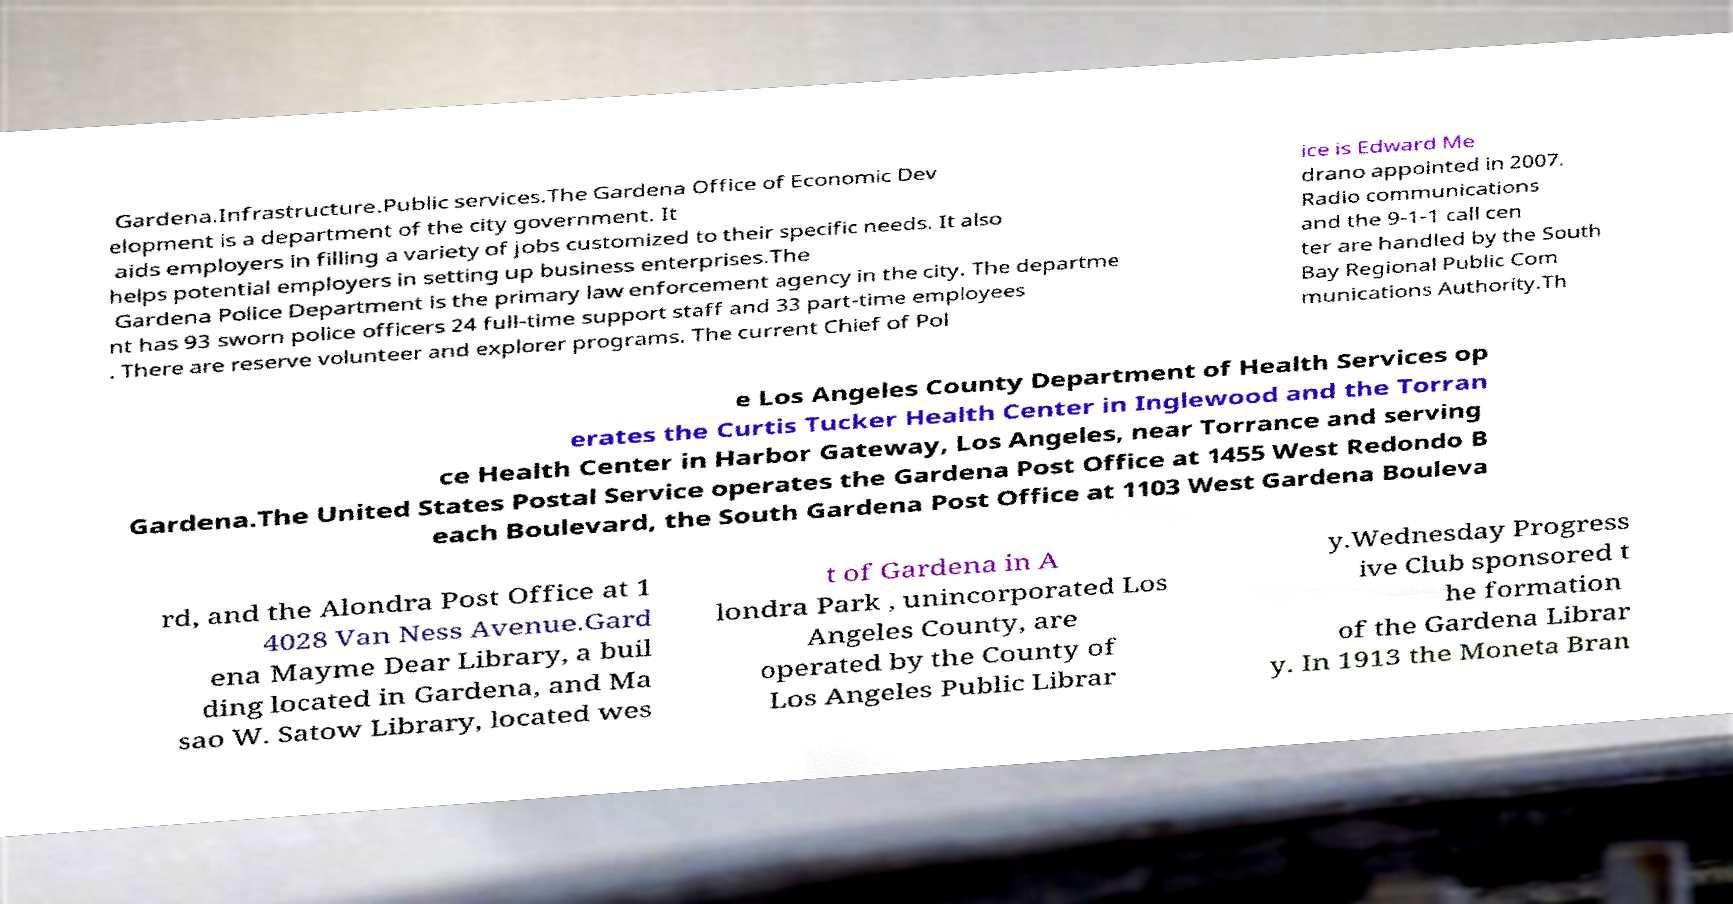Could you assist in decoding the text presented in this image and type it out clearly? Gardena.Infrastructure.Public services.The Gardena Office of Economic Dev elopment is a department of the city government. It aids employers in filling a variety of jobs customized to their specific needs. It also helps potential employers in setting up business enterprises.The Gardena Police Department is the primary law enforcement agency in the city. The departme nt has 93 sworn police officers 24 full-time support staff and 33 part-time employees . There are reserve volunteer and explorer programs. The current Chief of Pol ice is Edward Me drano appointed in 2007. Radio communications and the 9-1-1 call cen ter are handled by the South Bay Regional Public Com munications Authority.Th e Los Angeles County Department of Health Services op erates the Curtis Tucker Health Center in Inglewood and the Torran ce Health Center in Harbor Gateway, Los Angeles, near Torrance and serving Gardena.The United States Postal Service operates the Gardena Post Office at 1455 West Redondo B each Boulevard, the South Gardena Post Office at 1103 West Gardena Bouleva rd, and the Alondra Post Office at 1 4028 Van Ness Avenue.Gard ena Mayme Dear Library, a buil ding located in Gardena, and Ma sao W. Satow Library, located wes t of Gardena in A londra Park , unincorporated Los Angeles County, are operated by the County of Los Angeles Public Librar y.Wednesday Progress ive Club sponsored t he formation of the Gardena Librar y. In 1913 the Moneta Bran 